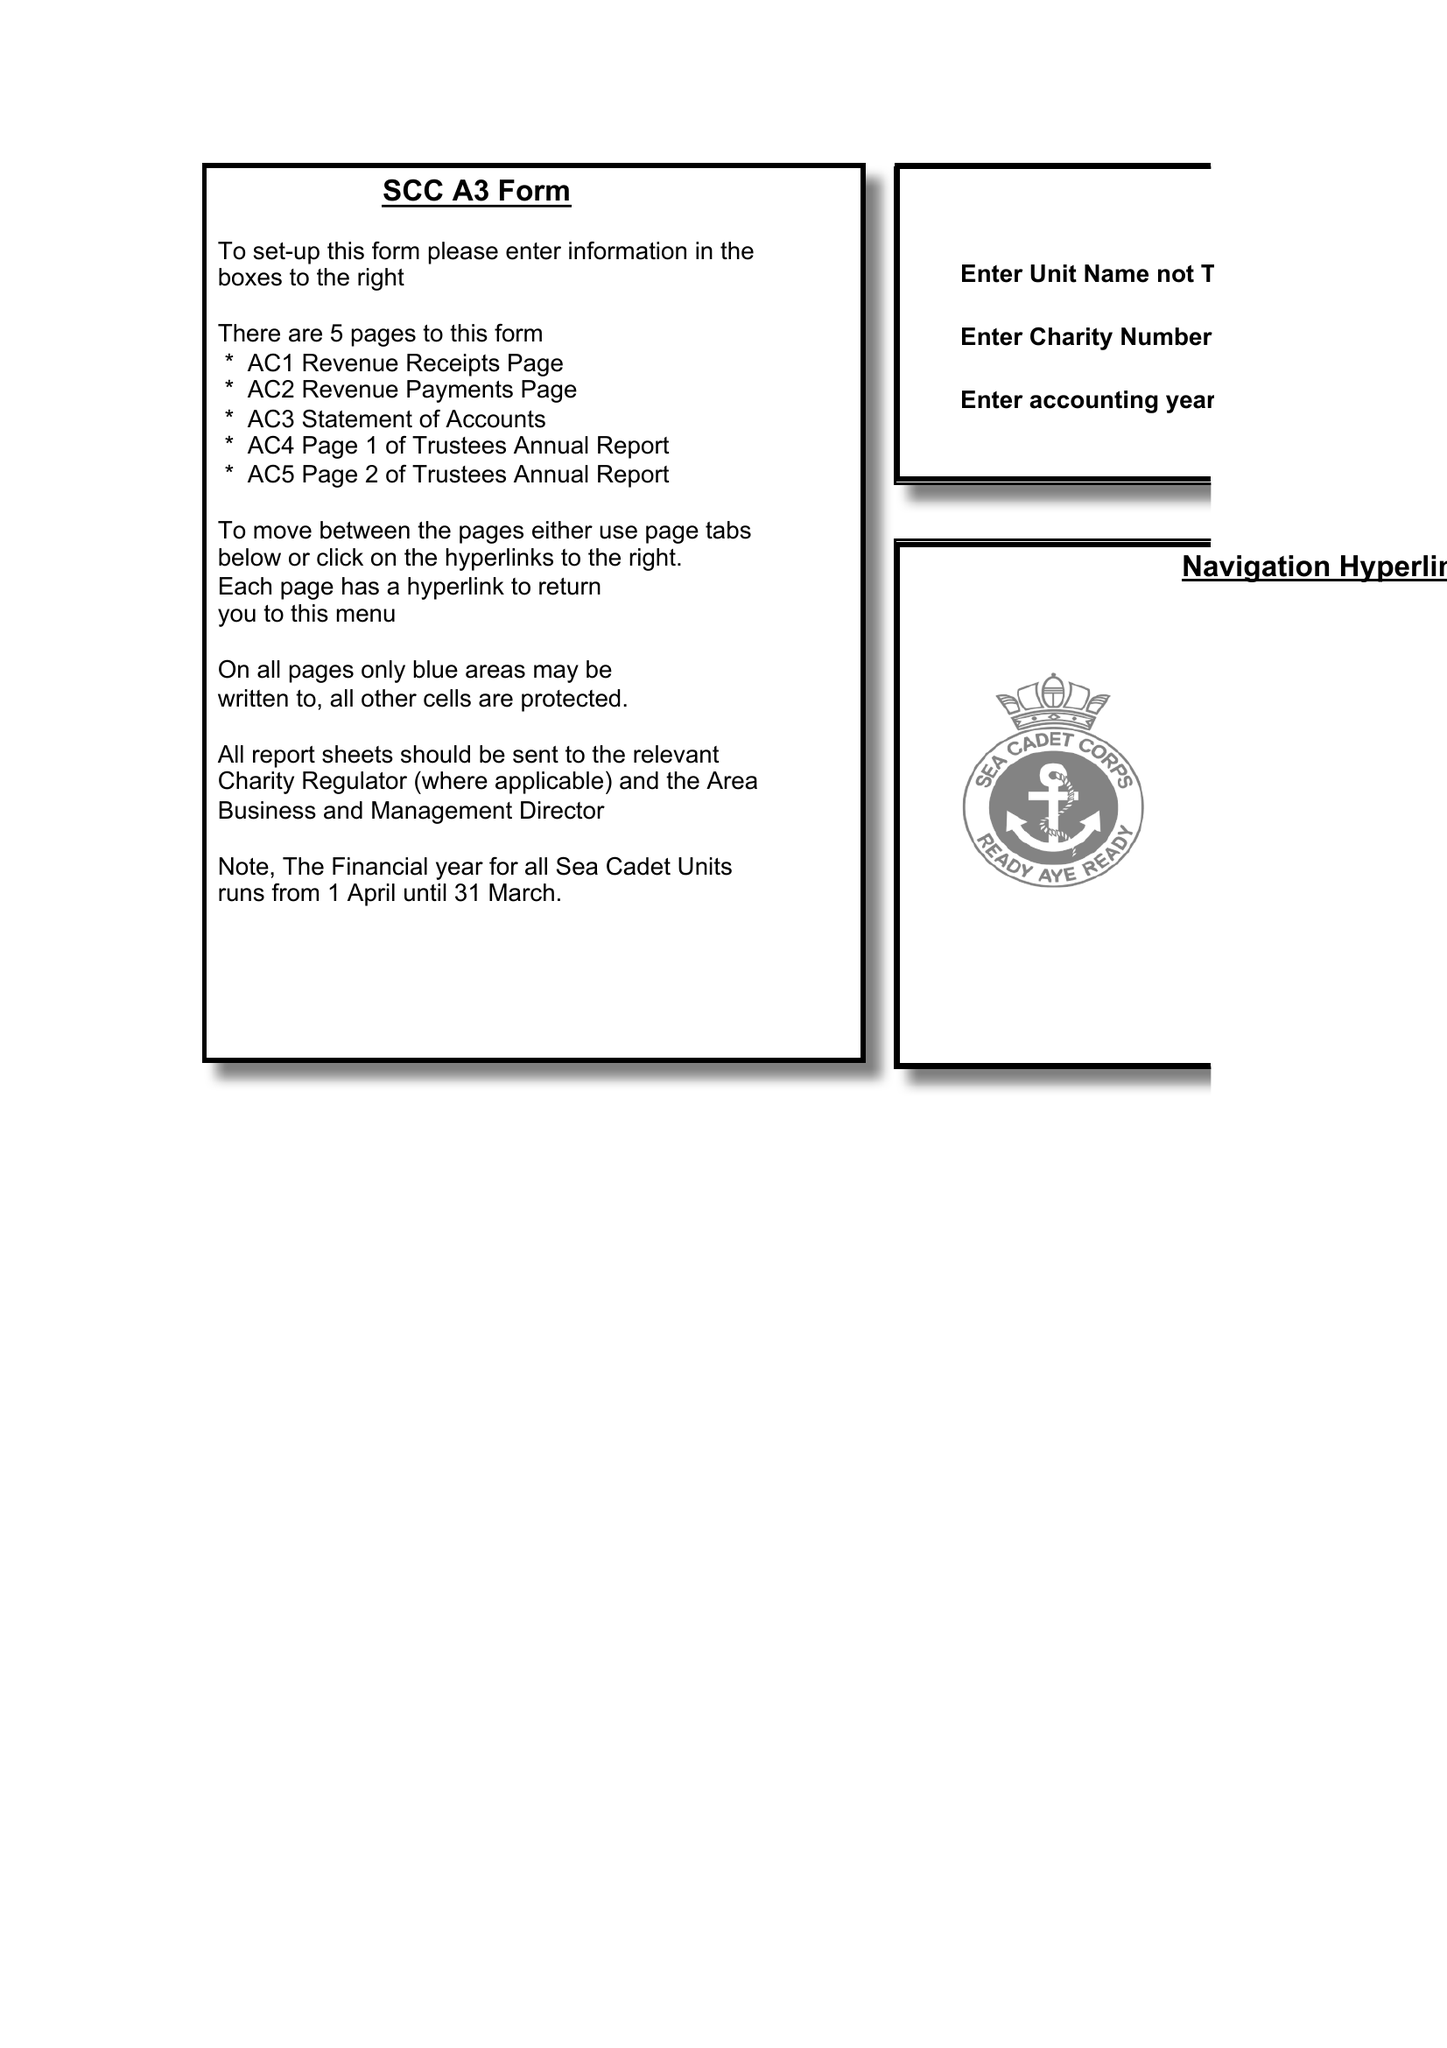What is the value for the address__postcode?
Answer the question using a single word or phrase. CF36 3UU 